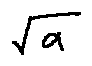Convert formula to latex. <formula><loc_0><loc_0><loc_500><loc_500>\sqrt { a }</formula> 